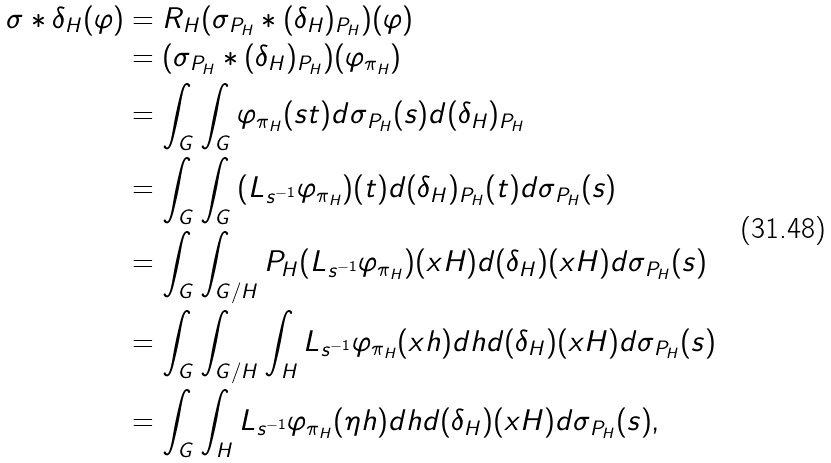Convert formula to latex. <formula><loc_0><loc_0><loc_500><loc_500>\sigma \ast \delta _ { H } ( \varphi ) & = R _ { H } ( \sigma _ { P _ { H } } \ast ( \delta _ { H } ) _ { P _ { H } } ) ( \varphi ) \\ & = ( \sigma _ { P _ { H } } \ast ( \delta _ { H } ) _ { P _ { H } } ) ( \varphi _ { \pi _ { H } } ) \\ & = \int _ { G } { \int _ { G } { \varphi _ { \pi _ { H } } ( s t ) d \sigma _ { P _ { H } } ( s ) d ( \delta _ { H } ) _ { P _ { H } } } } \\ & = \int _ { G } { \int _ { G } { ( L _ { s ^ { - 1 } } \varphi _ { \pi _ { H } } ) ( t ) d ( \delta _ { H } ) _ { P _ { H } } ( t ) d \sigma _ { P _ { H } } ( s ) } } \\ & = \int _ { G } { \int _ { G / H } { P _ { H } ( L _ { s ^ { - 1 } } \varphi _ { \pi _ { H } } ) ( x H ) d ( \delta _ { H } ) ( x H ) d \sigma _ { P _ { H } } ( s ) } } \\ & = \int _ { G } { \int _ { G / H } { \int _ { H } { L _ { s ^ { - 1 } } \varphi _ { \pi _ { H } } ( x h ) d h d ( \delta _ { H } ) ( x H ) d \sigma _ { P _ { H } } ( s ) } } } \\ & = \int _ { G } { \int _ { H } { L _ { s ^ { - 1 } } \varphi _ { \pi _ { H } } ( \eta h ) d h d ( \delta _ { H } ) ( x H ) d \sigma _ { P _ { H } } ( s ) } } ,</formula> 